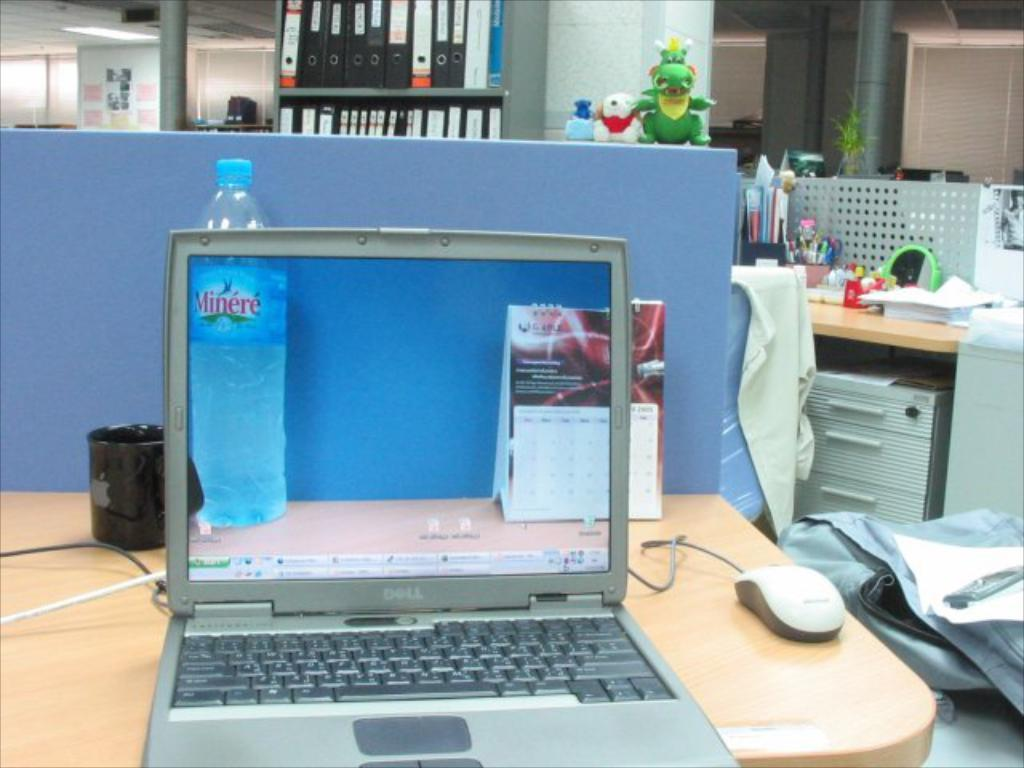What piece of furniture is visible in the image? There is a table in the image. What electronic device is on the table? The table has a laptop on it. What type of beverage container is on the table? There is a water bottle on the table. What is the other drink container on the table? A mug is present on the table. What accessory is used for controlling the laptop? There is a mouse on the table. What can be seen in the background of the image? There are files in the background of the image. What type of bun is being used to hold the laptop in place on the table? There is no bun present in the image; the laptop is simply placed on the table. What is the person's interest in the image? The image does not provide information about the person's interests. 